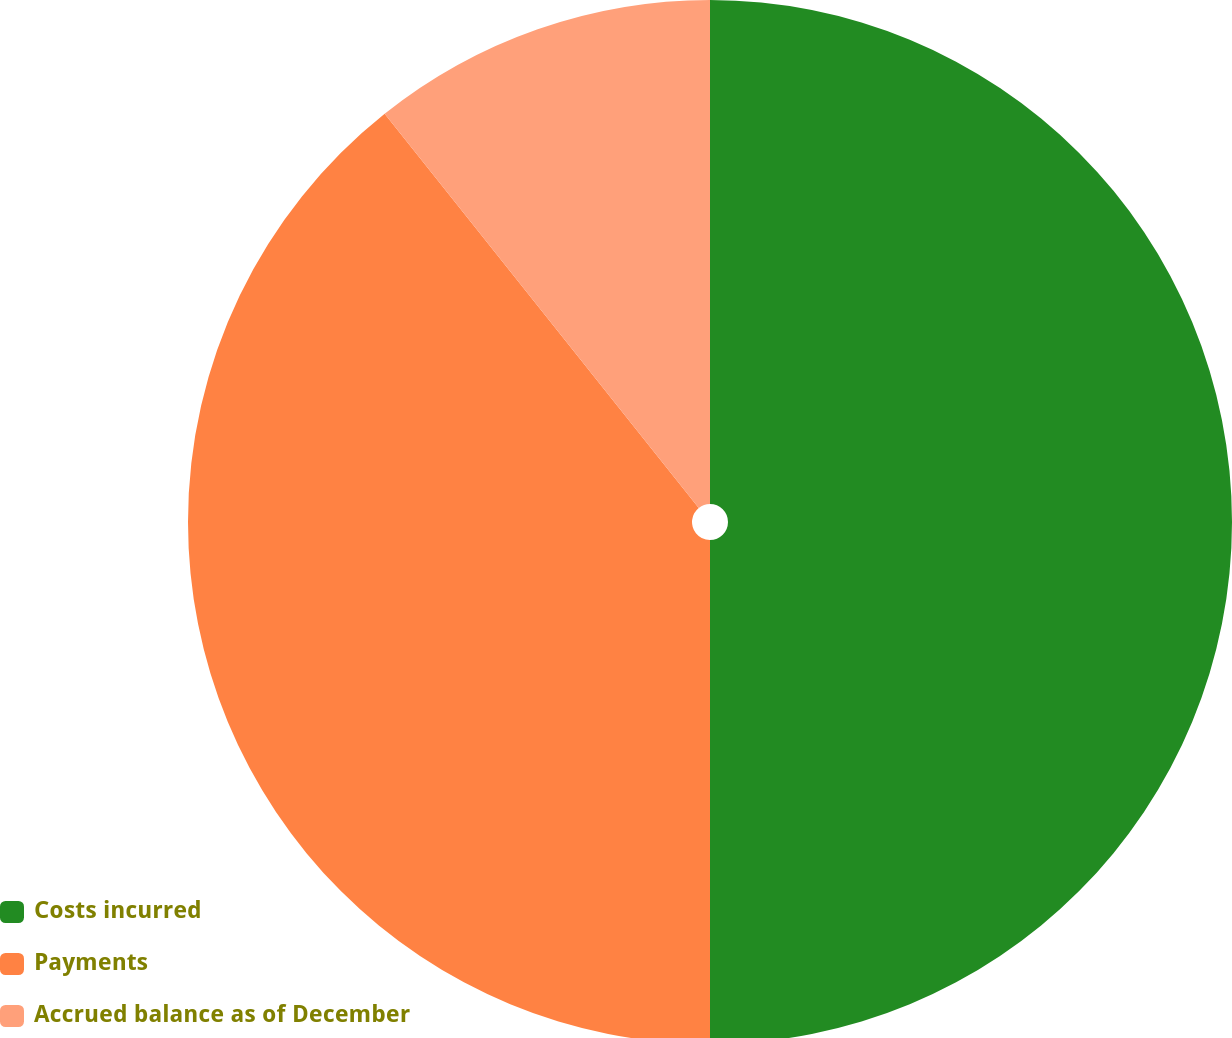<chart> <loc_0><loc_0><loc_500><loc_500><pie_chart><fcel>Costs incurred<fcel>Payments<fcel>Accrued balance as of December<nl><fcel>50.0%<fcel>39.29%<fcel>10.71%<nl></chart> 